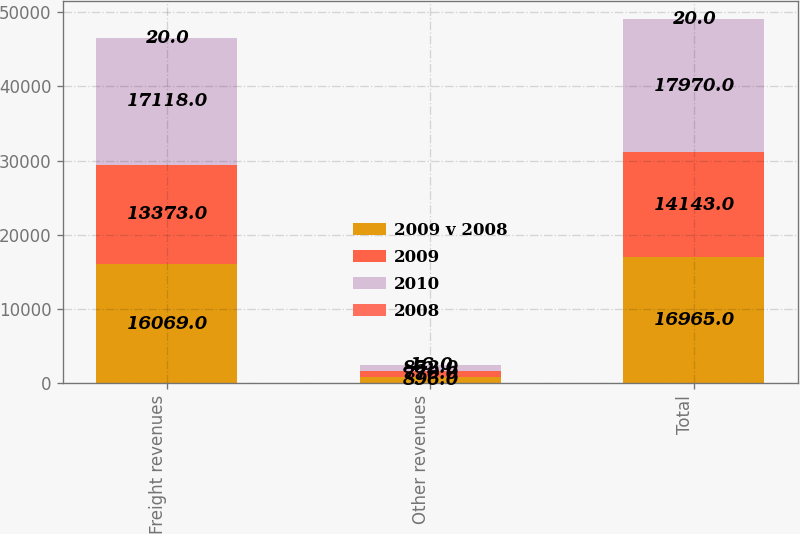Convert chart to OTSL. <chart><loc_0><loc_0><loc_500><loc_500><stacked_bar_chart><ecel><fcel>Freight revenues<fcel>Other revenues<fcel>Total<nl><fcel>2009 v 2008<fcel>16069<fcel>896<fcel>16965<nl><fcel>2009<fcel>13373<fcel>770<fcel>14143<nl><fcel>2010<fcel>17118<fcel>852<fcel>17970<nl><fcel>2008<fcel>20<fcel>16<fcel>20<nl></chart> 